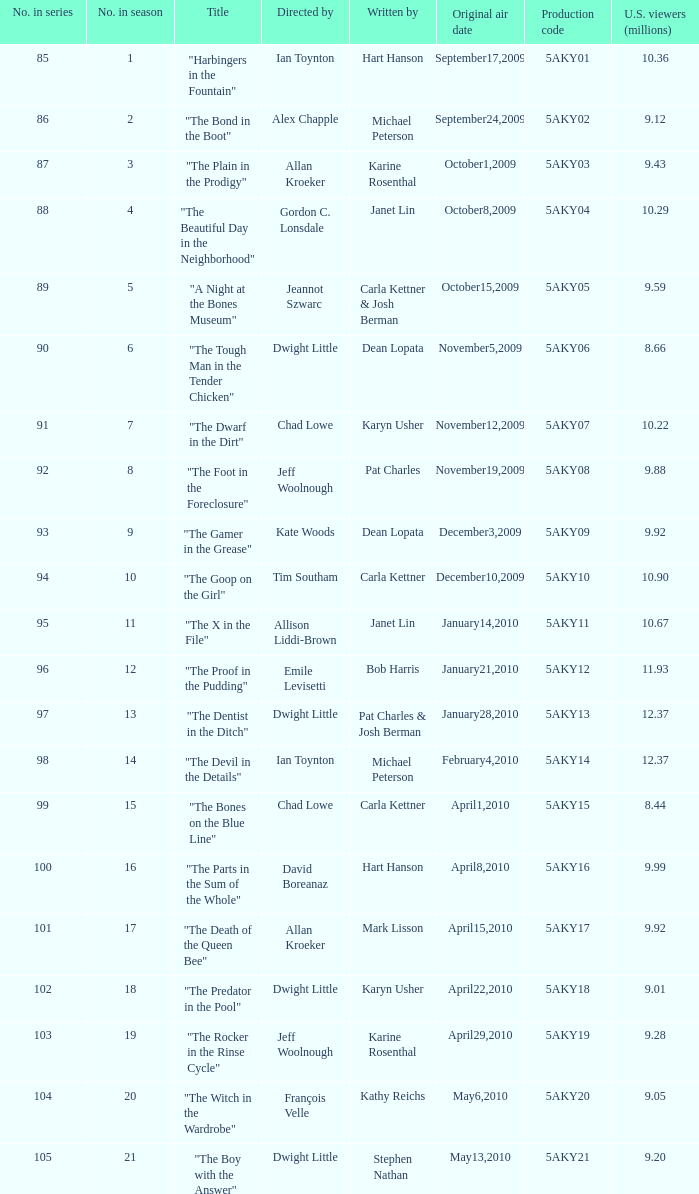How many were the US viewers (in millions) of the episode that was written by Gordon C. Lonsdale? 10.29. 